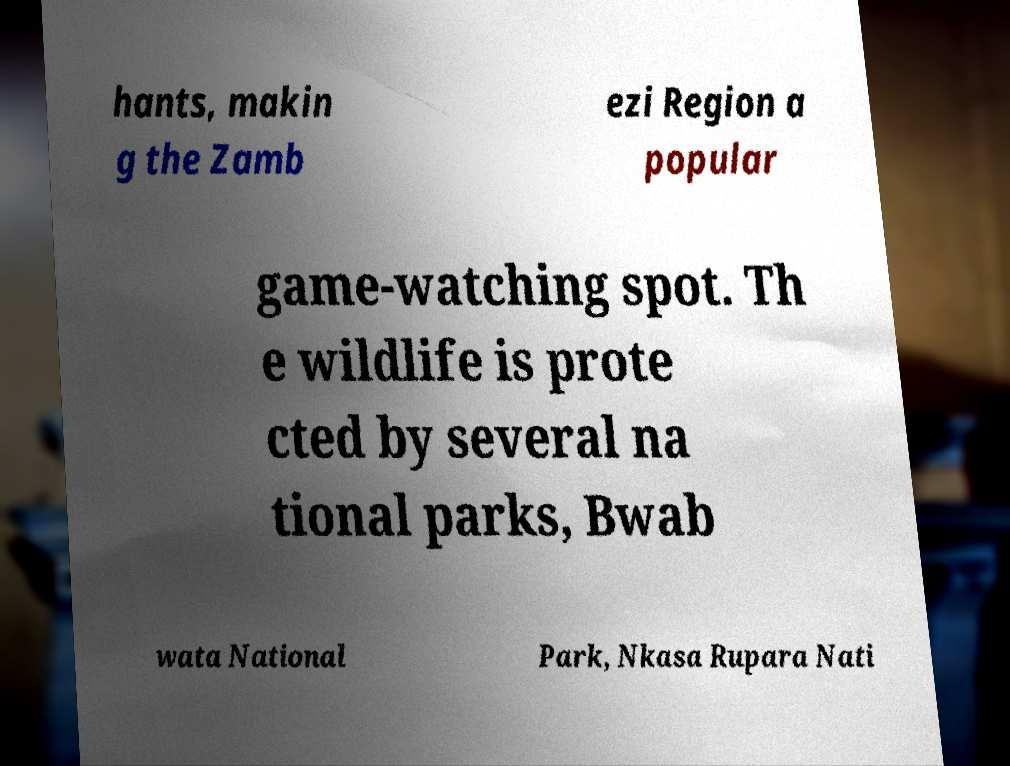Can you accurately transcribe the text from the provided image for me? hants, makin g the Zamb ezi Region a popular game-watching spot. Th e wildlife is prote cted by several na tional parks, Bwab wata National Park, Nkasa Rupara Nati 